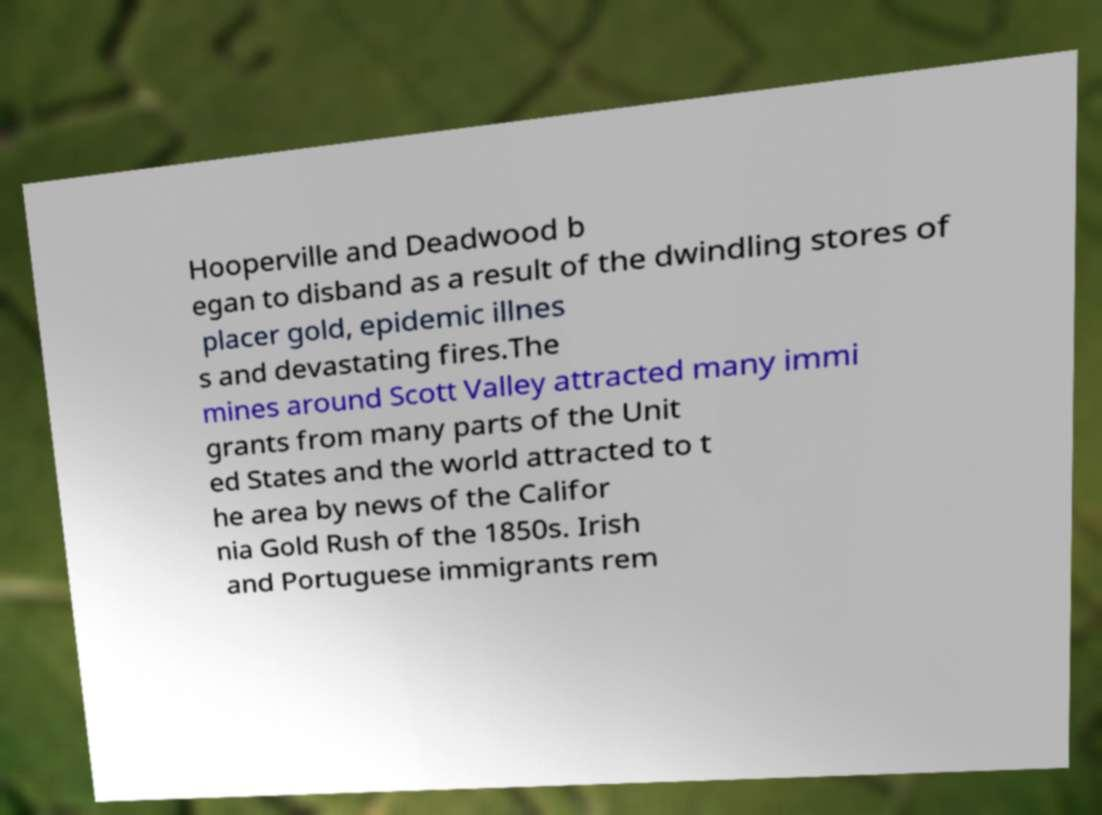Could you extract and type out the text from this image? Hooperville and Deadwood b egan to disband as a result of the dwindling stores of placer gold, epidemic illnes s and devastating fires.The mines around Scott Valley attracted many immi grants from many parts of the Unit ed States and the world attracted to t he area by news of the Califor nia Gold Rush of the 1850s. Irish and Portuguese immigrants rem 